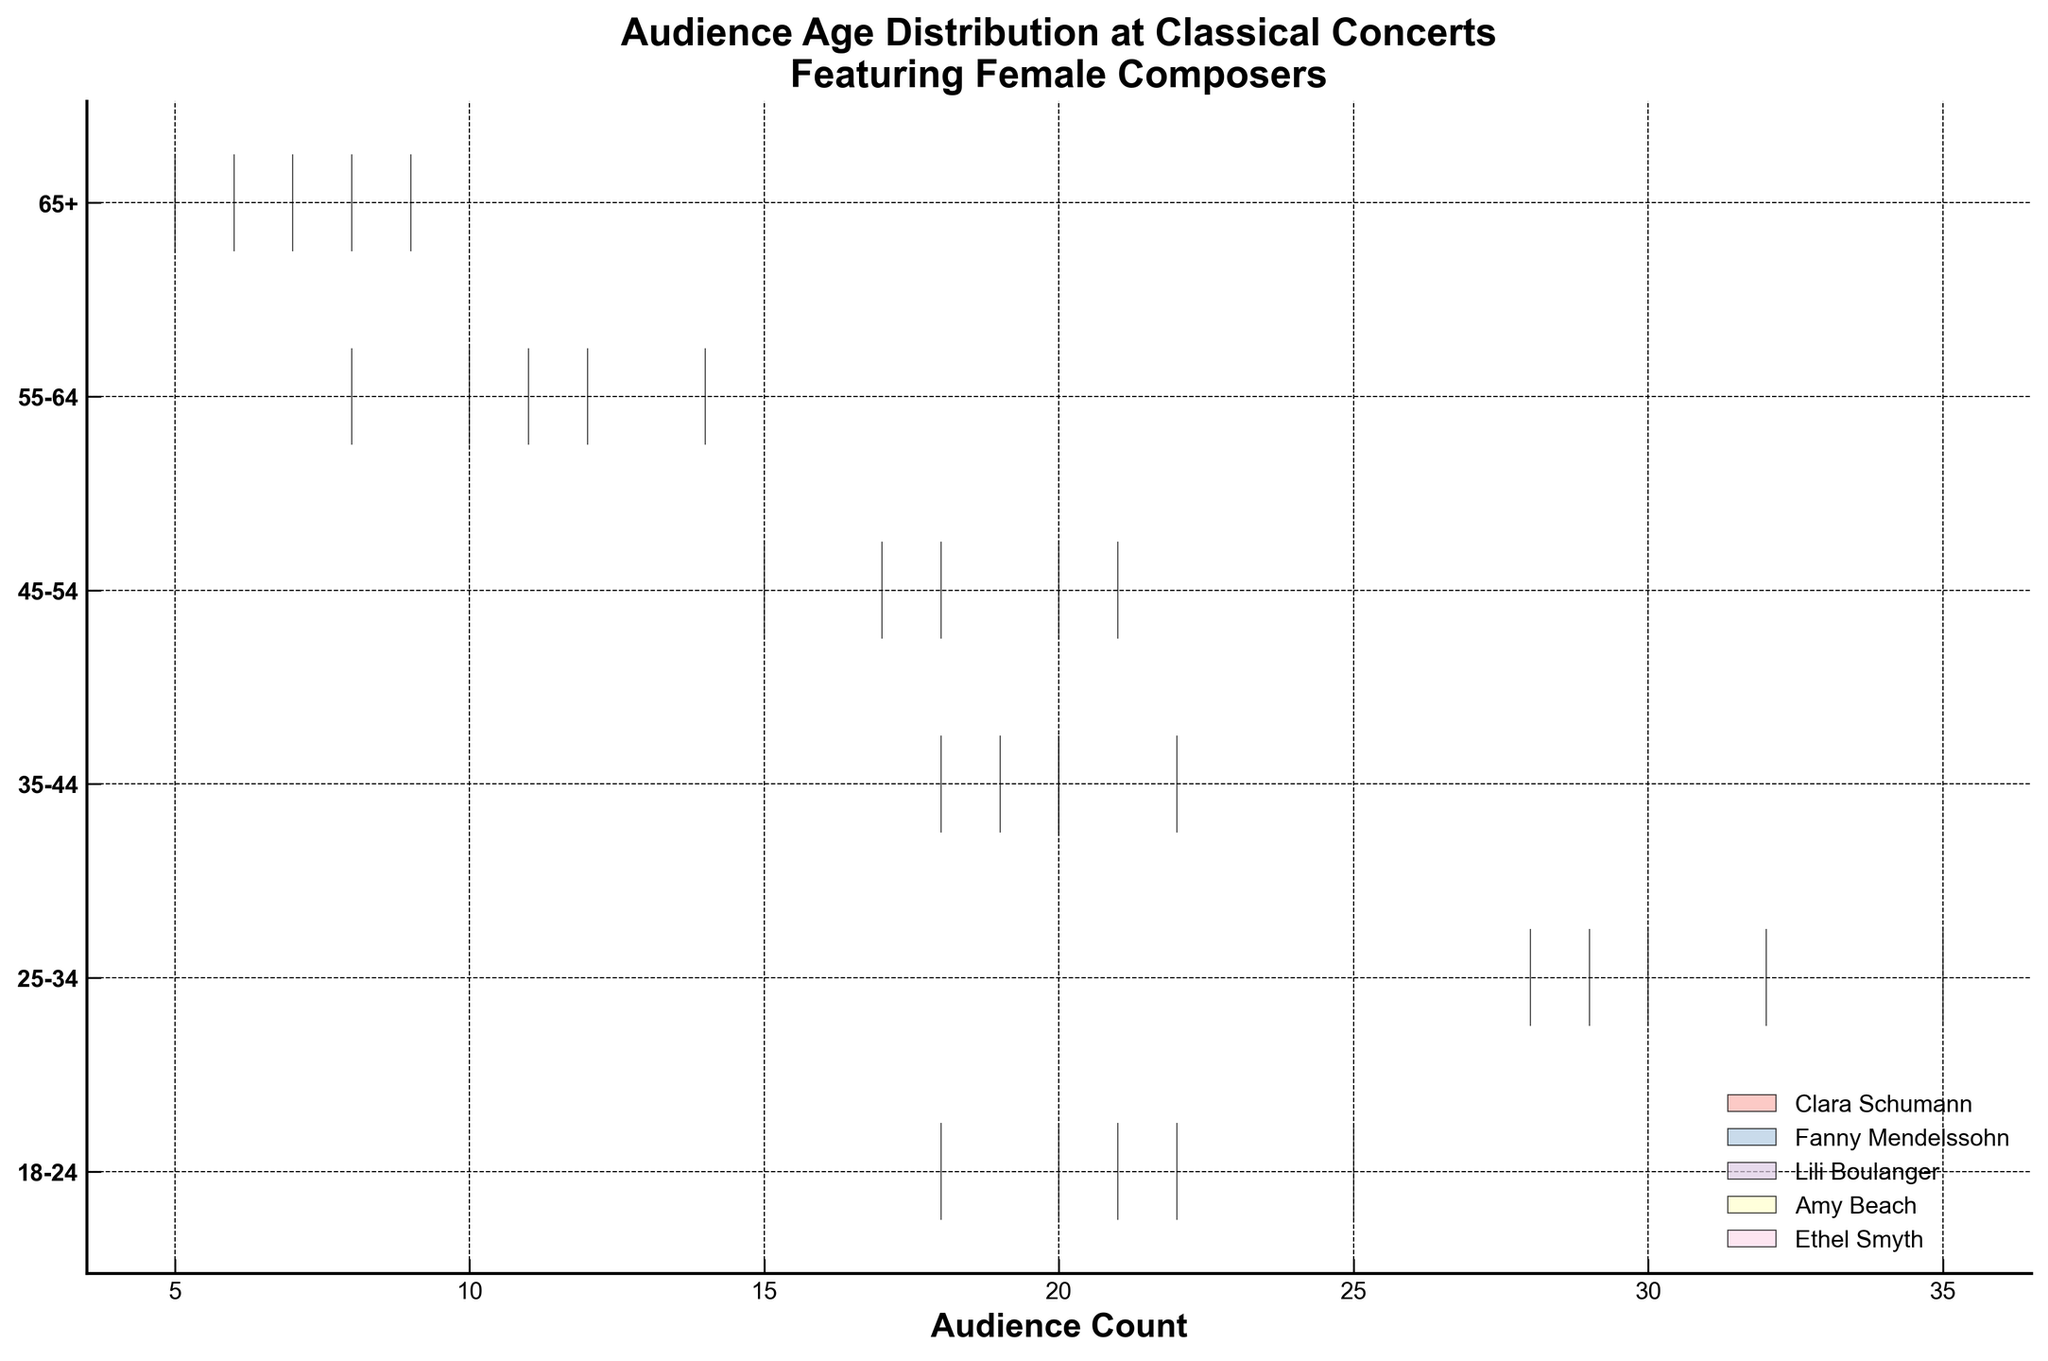What is the title of the chart? The title is the text located at the top of the chart. It provides context by indicating what the chart is about. Here, the title is "Audience Age Distribution at Classical Concerts Featuring Female Composers".
Answer: Audience Age Distribution at Classical Concerts Featuring Female Composers Which axis represents the age ranges? The age ranges are listed along the vertical axis, as it displays categories like 18-24, 25-34, etc. The horizontal axis represents audience count instead.
Answer: The vertical axis What is the highest audience count for Clara Schumann's concerts in any age range? To find this, look for the longest segment in the violin plots that correspond to Clara Schumann. The longest segment for her is in the 25-34 age range. The legend shows that the color matching Clara Schumann reveals the highest count of 35.
Answer: 35 What is the sum of audience counts for Ethel Smyth in the 25-34 and 45-54 age ranges? Look at the sections of the violin plot for Ethel Smyth (according to the color legend) and read the respective counts. Sum these values: 29 (25-34) + 17 (45-54).
Answer: 46 Which composer has the least audience counts in the 65+ age category? Examine the violin plots at the 65+ age range and locate which plot is the shortest, then refer to the legend to find the corresponding composer. In this case, it is Fanny Mendelssohn with a count of 5.
Answer: Fanny Mendelssohn How does the audience count for Lili Boulanger in the 35-44 age range compare to that in the 55-64 age range? Check the respective violin plot heights for Lili Boulanger. The 35-44 age range shows a height corresponding to 22 audience count, and the 55-64 range shows a height of 12.
Answer: The count is higher in the 35-44 age range What is the average audience count in the 18-24 age range across all composers? Add up the audience counts for each composer in the 18-24 age range: 22 (Clara Schumann) + 25 (Fanny Mendelssohn) + 20 (Lili Boulanger) + 18 (Amy Beach) + 21 (Ethel Smyth). Sum = 106. Divide by the number of composers, which is 5.
Answer: 21.2 Which age range has the highest overall audience count across all composers? Add the audience counts across all composers for each age range and compare them: 18-24, 25-34, 35-44, 45-54, 55-64, 65+. The highest sum is for 25-34.
Answer: 25-34 